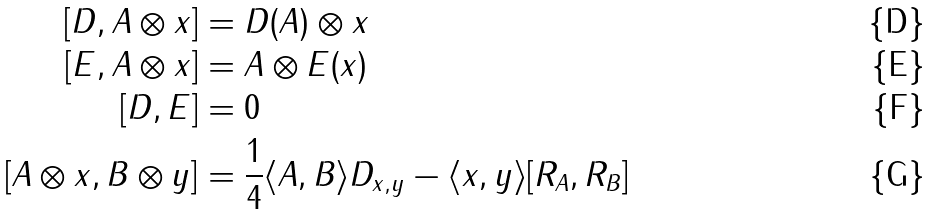<formula> <loc_0><loc_0><loc_500><loc_500>[ D , A \otimes x ] & = D ( A ) \otimes x \\ [ E , A \otimes x ] & = A \otimes E ( x ) \\ [ D , E ] & = 0 \\ [ A \otimes x , B \otimes y ] & = \frac { 1 } { 4 } \langle A , B \rangle D _ { x , y } - \langle x , y \rangle [ R _ { A } , R _ { B } ]</formula> 